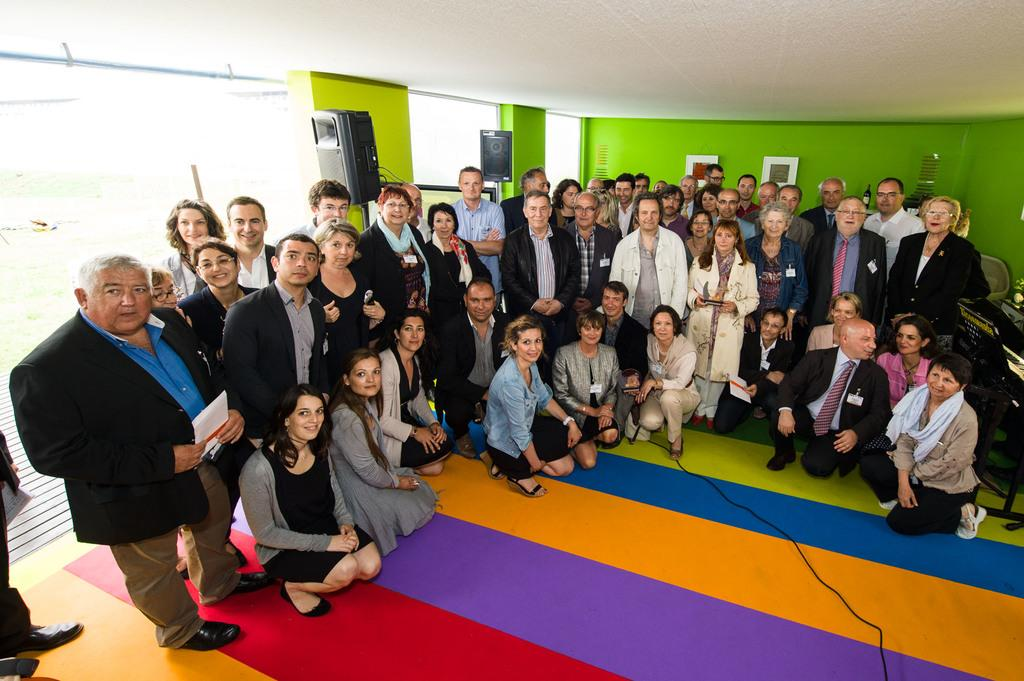What are the people in the image doing? There are people standing and sitting in the image. What can be seen in the background of the image? There is a wall in the background of the image. What objects are visible that might be used for amplifying sound? There are speakers visible in the image. What is the man on the left side of the image holding? The man on the left side of the image is holding a paper. What type of question is being asked in the image? There is no indication of a question being asked in the image. Is there any trade happening in the image? There is no indication of any trade occurring in the image. 